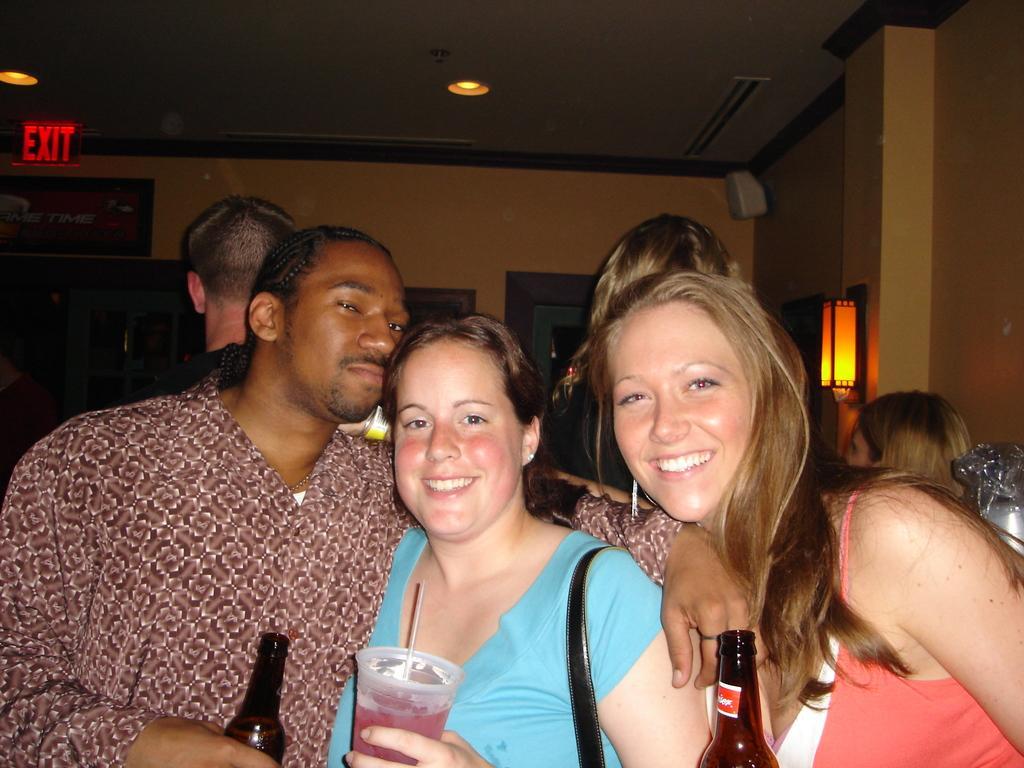Could you give a brief overview of what you see in this image? This image is taken indoors. In the background there is a wall with a door and there is a lamp. At the top of the image there is a ceiling with a few lights and there is a signboard with a text on it. In the middle of the image a man and two women are standing and they are holding bottles and a tumbler in their hands. They are with smiling faces. In the background there are a few people. 